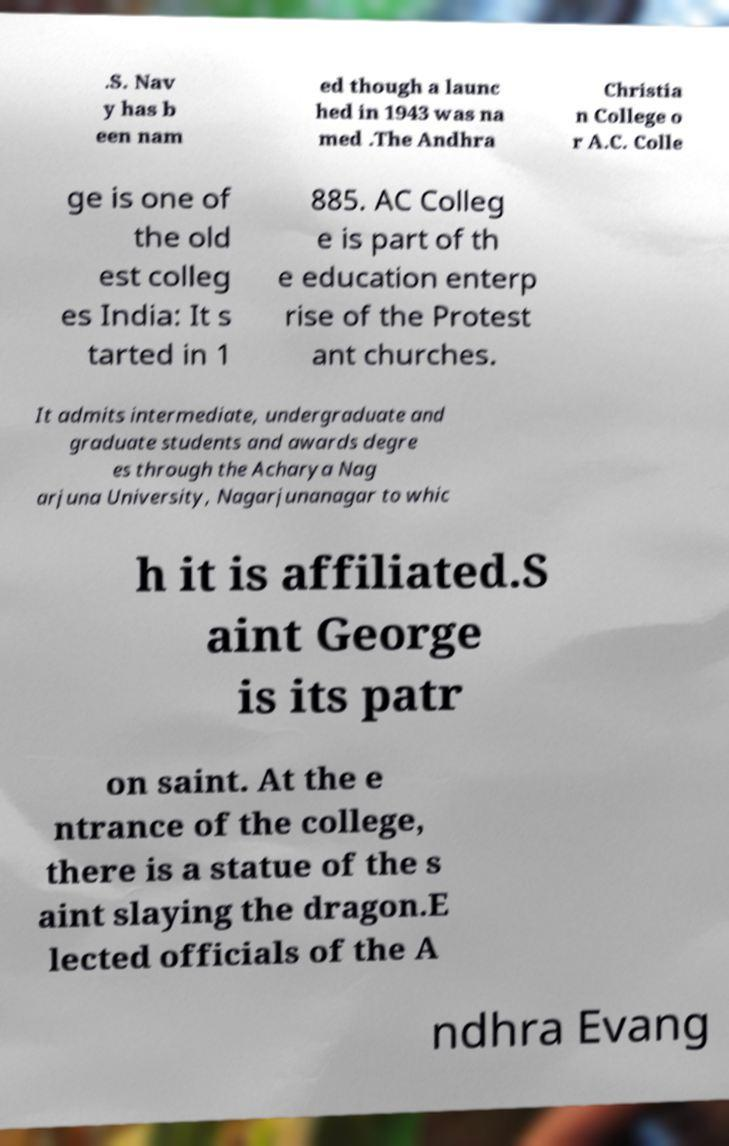Could you extract and type out the text from this image? .S. Nav y has b een nam ed though a launc hed in 1943 was na med .The Andhra Christia n College o r A.C. Colle ge is one of the old est colleg es India: It s tarted in 1 885. AC Colleg e is part of th e education enterp rise of the Protest ant churches. It admits intermediate, undergraduate and graduate students and awards degre es through the Acharya Nag arjuna University, Nagarjunanagar to whic h it is affiliated.S aint George is its patr on saint. At the e ntrance of the college, there is a statue of the s aint slaying the dragon.E lected officials of the A ndhra Evang 